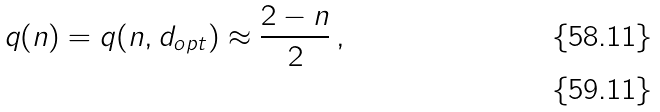<formula> <loc_0><loc_0><loc_500><loc_500>q ( n ) = q ( n , d _ { o p t } ) \approx \frac { 2 - n } { 2 } \, , \\</formula> 